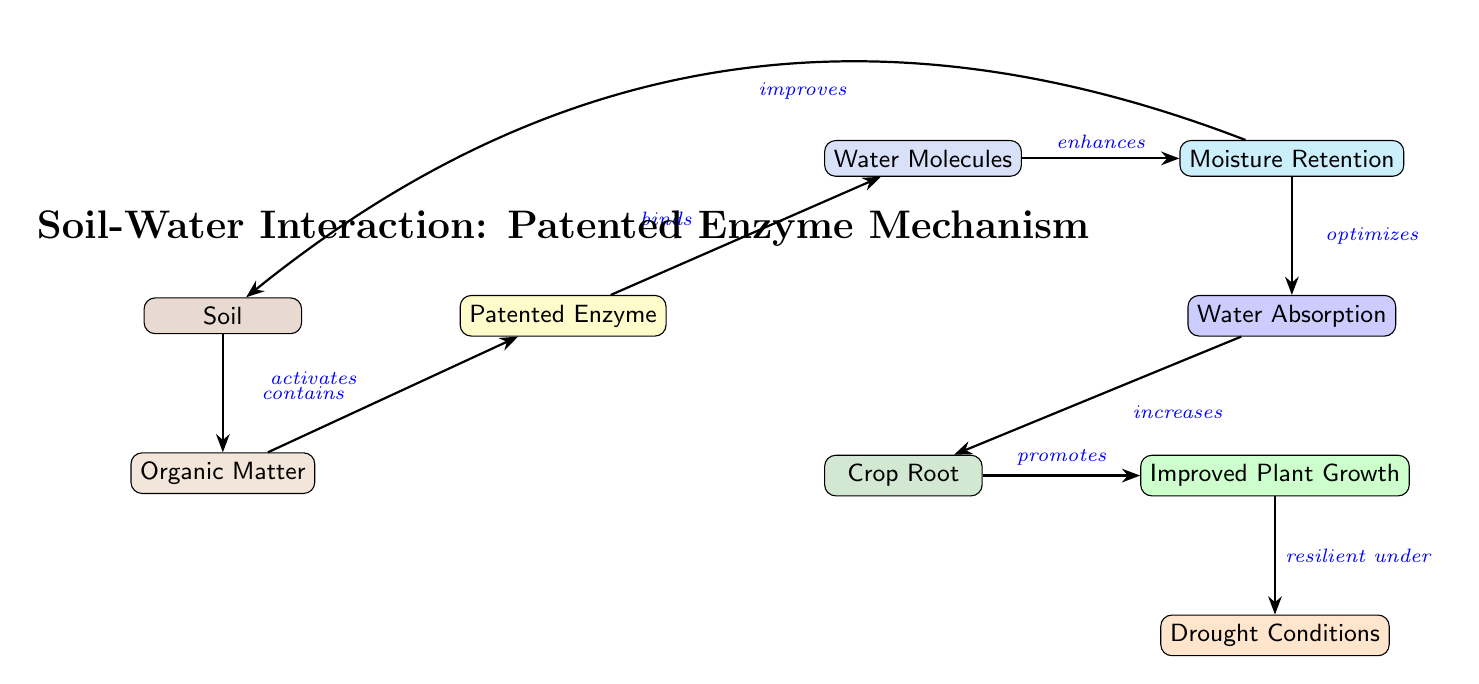What is the first component connected to organic matter? The diagram shows that organic matter is the first node connected to the soil, indicating that the soil contains organic matter.
Answer: Soil How many nodes are in the diagram? The diagram features a total of 9 nodes, each representing different components involved in soil-water interaction.
Answer: 9 What does the patented enzyme do to water molecules? The diagram indicates that the patented enzyme binds to water molecules, showing its role in water retention.
Answer: Binds What promotes improved plant growth according to the diagram? The diagram states that crop roots promote improved plant growth, showing how the absorption of water impacts plant health.
Answer: Crop Root How does moisture retention affect soil? The diagram reveals that moisture retention improves the soil, indicating that the patent enzyme enhances the water-holding capacity of the soil.
Answer: Improves What effect does the patented enzyme have under drought conditions? According to the diagram, improved plant growth is resilient under drought conditions due to the actions of the patented enzyme.
Answer: Resilient What is enhanced by binding of the patented enzyme to water? The diagram specifies that binding of the patented enzyme to water enhances moisture retention, indicating its effect on soil moisture.
Answer: Moisture Retention Which component directly influences water absorption? The diagram illustrates that moisture retention optimizes water absorption, showing the flow of benefits through the system.
Answer: Moisture Retention 